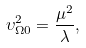Convert formula to latex. <formula><loc_0><loc_0><loc_500><loc_500>\upsilon _ { \Omega 0 } ^ { 2 } = \frac { \mu ^ { 2 } } { \lambda } ,</formula> 